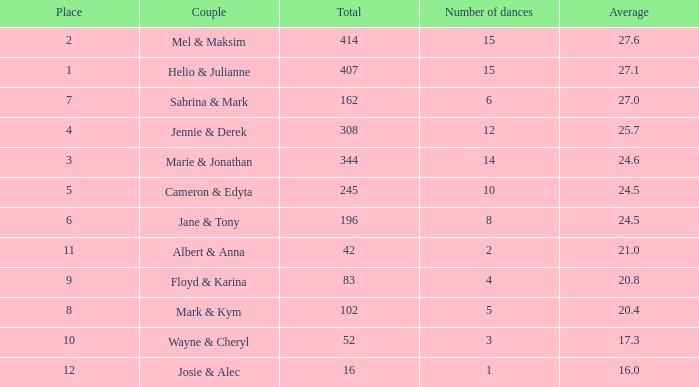What is the rank by average where the total was larger than 245 and the average was 27.1 with fewer than 15 dances? None. Can you give me this table as a dict? {'header': ['Place', 'Couple', 'Total', 'Number of dances', 'Average'], 'rows': [['2', 'Mel & Maksim', '414', '15', '27.6'], ['1', 'Helio & Julianne', '407', '15', '27.1'], ['7', 'Sabrina & Mark', '162', '6', '27.0'], ['4', 'Jennie & Derek', '308', '12', '25.7'], ['3', 'Marie & Jonathan', '344', '14', '24.6'], ['5', 'Cameron & Edyta', '245', '10', '24.5'], ['6', 'Jane & Tony', '196', '8', '24.5'], ['11', 'Albert & Anna', '42', '2', '21.0'], ['9', 'Floyd & Karina', '83', '4', '20.8'], ['8', 'Mark & Kym', '102', '5', '20.4'], ['10', 'Wayne & Cheryl', '52', '3', '17.3'], ['12', 'Josie & Alec', '16', '1', '16.0']]} 